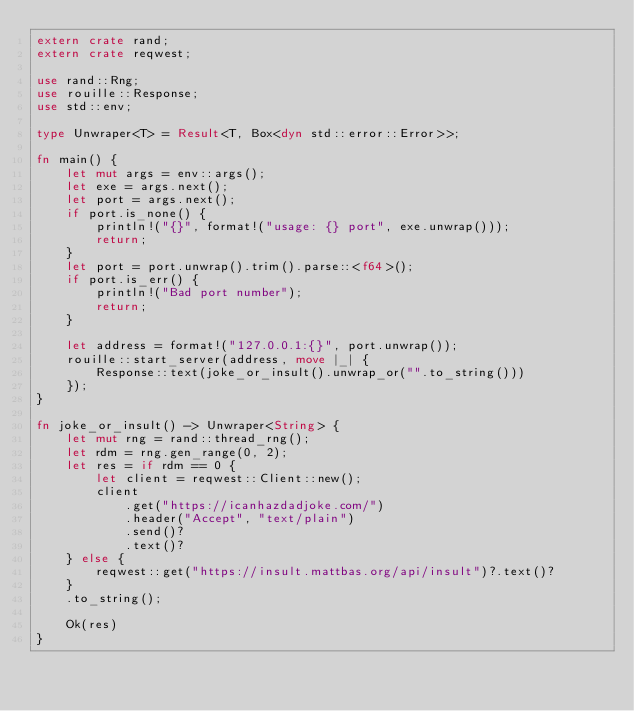Convert code to text. <code><loc_0><loc_0><loc_500><loc_500><_Rust_>extern crate rand;
extern crate reqwest;

use rand::Rng;
use rouille::Response;
use std::env;

type Unwraper<T> = Result<T, Box<dyn std::error::Error>>;

fn main() {
    let mut args = env::args();
    let exe = args.next();
    let port = args.next();
    if port.is_none() {
        println!("{}", format!("usage: {} port", exe.unwrap()));
        return;
    }
    let port = port.unwrap().trim().parse::<f64>();
    if port.is_err() {
        println!("Bad port number");
        return;
    }

    let address = format!("127.0.0.1:{}", port.unwrap());
    rouille::start_server(address, move |_| {
        Response::text(joke_or_insult().unwrap_or("".to_string()))
    });
}

fn joke_or_insult() -> Unwraper<String> {
    let mut rng = rand::thread_rng();
    let rdm = rng.gen_range(0, 2);
    let res = if rdm == 0 {
        let client = reqwest::Client::new();
        client
            .get("https://icanhazdadjoke.com/")
            .header("Accept", "text/plain")
            .send()?
            .text()?
    } else {
        reqwest::get("https://insult.mattbas.org/api/insult")?.text()?
    }
    .to_string();

    Ok(res)
}
</code> 